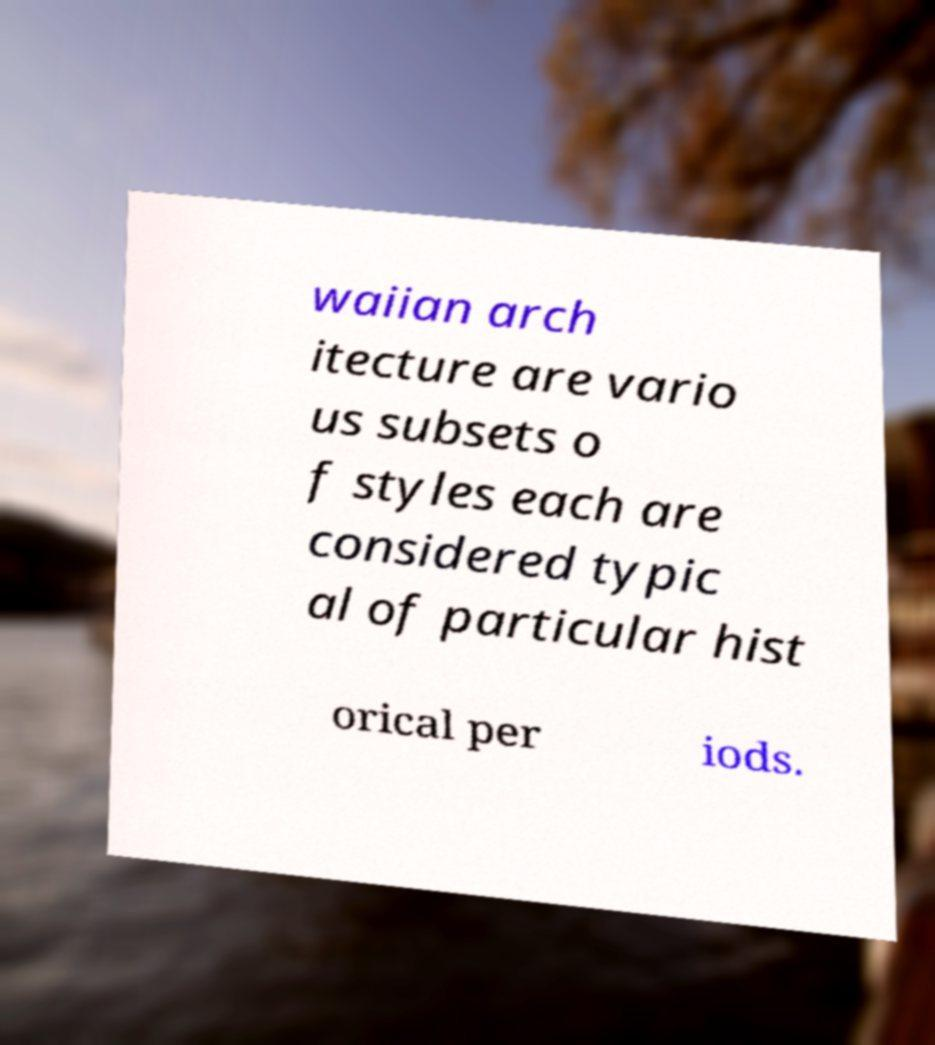Please read and relay the text visible in this image. What does it say? waiian arch itecture are vario us subsets o f styles each are considered typic al of particular hist orical per iods. 